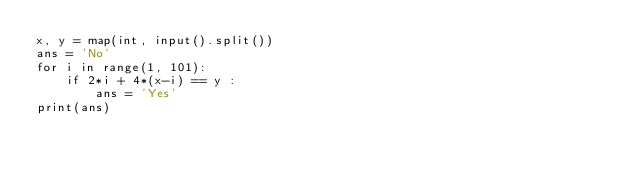Convert code to text. <code><loc_0><loc_0><loc_500><loc_500><_Python_>x, y = map(int, input().split())
ans = 'No'
for i in range(1, 101):
    if 2*i + 4*(x-i) == y :
        ans = 'Yes'
print(ans)
</code> 